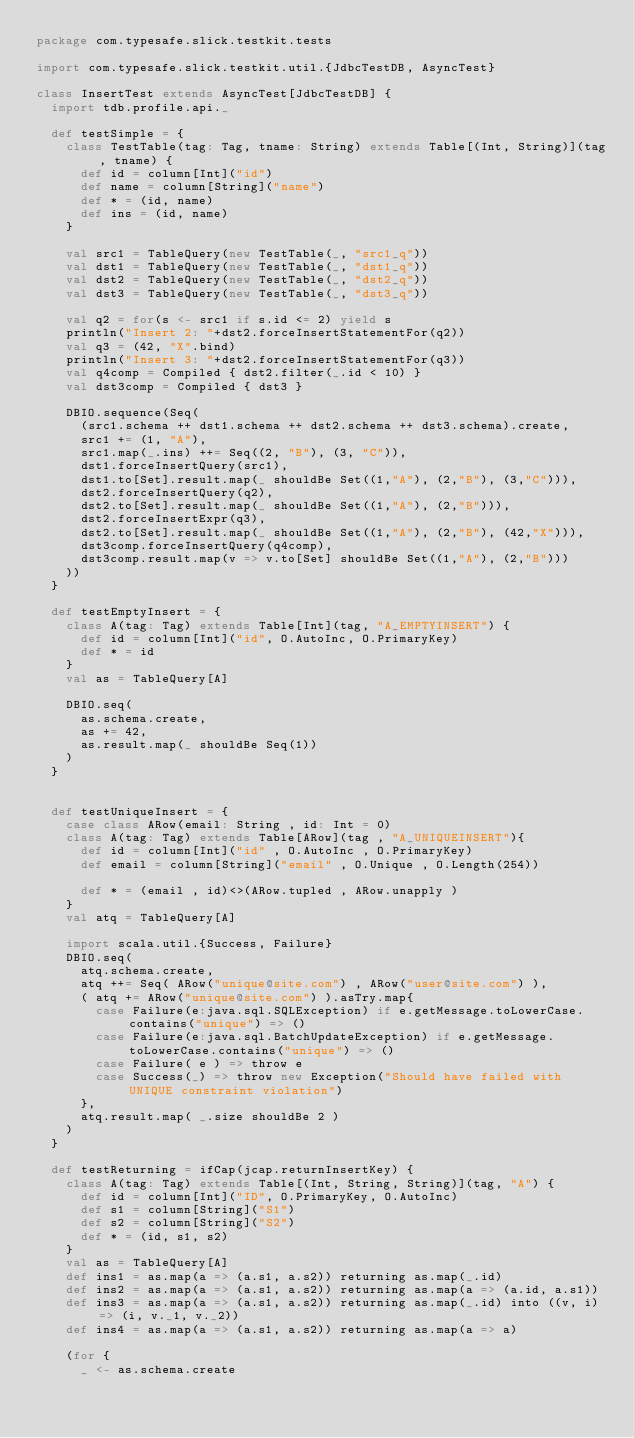<code> <loc_0><loc_0><loc_500><loc_500><_Scala_>package com.typesafe.slick.testkit.tests

import com.typesafe.slick.testkit.util.{JdbcTestDB, AsyncTest}

class InsertTest extends AsyncTest[JdbcTestDB] {
  import tdb.profile.api._

  def testSimple = {
    class TestTable(tag: Tag, tname: String) extends Table[(Int, String)](tag, tname) {
      def id = column[Int]("id")
      def name = column[String]("name")
      def * = (id, name)
      def ins = (id, name)
    }

    val src1 = TableQuery(new TestTable(_, "src1_q"))
    val dst1 = TableQuery(new TestTable(_, "dst1_q"))
    val dst2 = TableQuery(new TestTable(_, "dst2_q"))
    val dst3 = TableQuery(new TestTable(_, "dst3_q"))

    val q2 = for(s <- src1 if s.id <= 2) yield s
    println("Insert 2: "+dst2.forceInsertStatementFor(q2))
    val q3 = (42, "X".bind)
    println("Insert 3: "+dst2.forceInsertStatementFor(q3))
    val q4comp = Compiled { dst2.filter(_.id < 10) }
    val dst3comp = Compiled { dst3 }

    DBIO.sequence(Seq(
      (src1.schema ++ dst1.schema ++ dst2.schema ++ dst3.schema).create,
      src1 += (1, "A"),
      src1.map(_.ins) ++= Seq((2, "B"), (3, "C")),
      dst1.forceInsertQuery(src1),
      dst1.to[Set].result.map(_ shouldBe Set((1,"A"), (2,"B"), (3,"C"))),
      dst2.forceInsertQuery(q2),
      dst2.to[Set].result.map(_ shouldBe Set((1,"A"), (2,"B"))),
      dst2.forceInsertExpr(q3),
      dst2.to[Set].result.map(_ shouldBe Set((1,"A"), (2,"B"), (42,"X"))),
      dst3comp.forceInsertQuery(q4comp),
      dst3comp.result.map(v => v.to[Set] shouldBe Set((1,"A"), (2,"B")))
    ))
  }

  def testEmptyInsert = {
    class A(tag: Tag) extends Table[Int](tag, "A_EMPTYINSERT") {
      def id = column[Int]("id", O.AutoInc, O.PrimaryKey)
      def * = id
    }
    val as = TableQuery[A]

    DBIO.seq(
      as.schema.create,
      as += 42,
      as.result.map(_ shouldBe Seq(1))
    )
  }

  
  def testUniqueInsert = {
    case class ARow(email: String , id: Int = 0)
    class A(tag: Tag) extends Table[ARow](tag , "A_UNIQUEINSERT"){
      def id = column[Int]("id" , O.AutoInc , O.PrimaryKey)
      def email = column[String]("email" , O.Unique , O.Length(254))

      def * = (email , id)<>(ARow.tupled , ARow.unapply )
    }
    val atq = TableQuery[A]

    import scala.util.{Success, Failure}
    DBIO.seq(
      atq.schema.create,
      atq ++= Seq( ARow("unique@site.com") , ARow("user@site.com") ),
      ( atq += ARow("unique@site.com") ).asTry.map{
        case Failure(e:java.sql.SQLException) if e.getMessage.toLowerCase.contains("unique") => ()
        case Failure(e:java.sql.BatchUpdateException) if e.getMessage.toLowerCase.contains("unique") => ()
        case Failure( e ) => throw e
        case Success(_) => throw new Exception("Should have failed with UNIQUE constraint violation")
      },
      atq.result.map( _.size shouldBe 2 )
    )
  }

  def testReturning = ifCap(jcap.returnInsertKey) {
    class A(tag: Tag) extends Table[(Int, String, String)](tag, "A") {
      def id = column[Int]("ID", O.PrimaryKey, O.AutoInc)
      def s1 = column[String]("S1")
      def s2 = column[String]("S2")
      def * = (id, s1, s2)
    }
    val as = TableQuery[A]
    def ins1 = as.map(a => (a.s1, a.s2)) returning as.map(_.id)
    def ins2 = as.map(a => (a.s1, a.s2)) returning as.map(a => (a.id, a.s1))
    def ins3 = as.map(a => (a.s1, a.s2)) returning as.map(_.id) into ((v, i) => (i, v._1, v._2))
    def ins4 = as.map(a => (a.s1, a.s2)) returning as.map(a => a)

    (for {
      _ <- as.schema.create</code> 